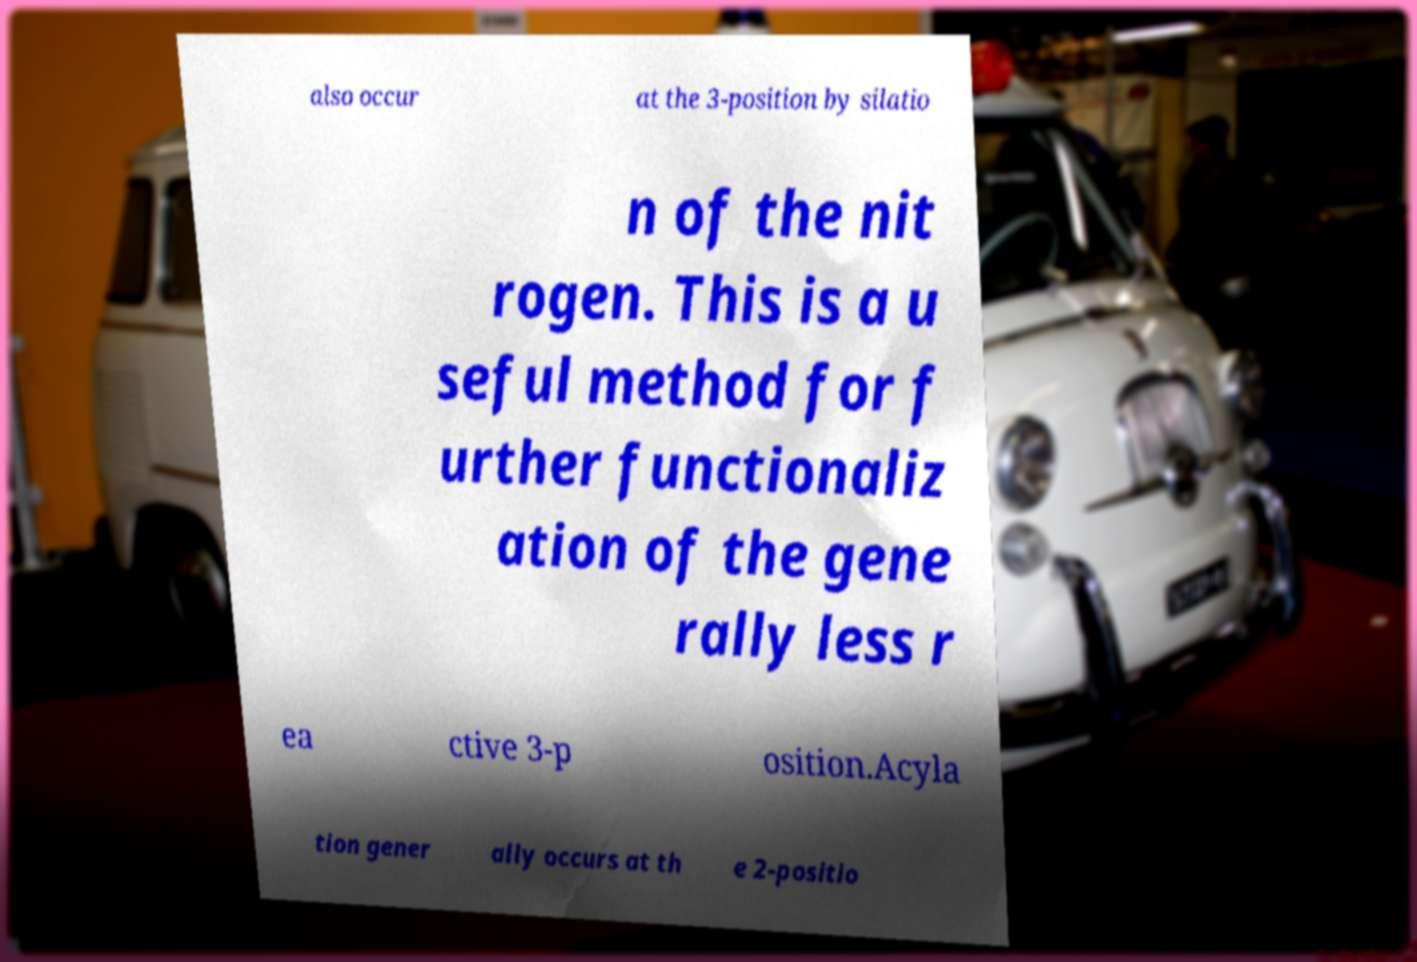There's text embedded in this image that I need extracted. Can you transcribe it verbatim? also occur at the 3-position by silatio n of the nit rogen. This is a u seful method for f urther functionaliz ation of the gene rally less r ea ctive 3-p osition.Acyla tion gener ally occurs at th e 2-positio 